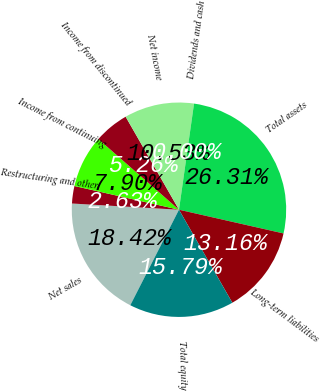Convert chart. <chart><loc_0><loc_0><loc_500><loc_500><pie_chart><fcel>Net sales<fcel>Restructuring and other<fcel>Income from continuing<fcel>Income from discontinued<fcel>Net income<fcel>Dividends and cash<fcel>Total assets<fcel>Long-term liabilities<fcel>Total equity<nl><fcel>18.42%<fcel>2.63%<fcel>7.9%<fcel>5.26%<fcel>10.53%<fcel>0.0%<fcel>26.31%<fcel>13.16%<fcel>15.79%<nl></chart> 